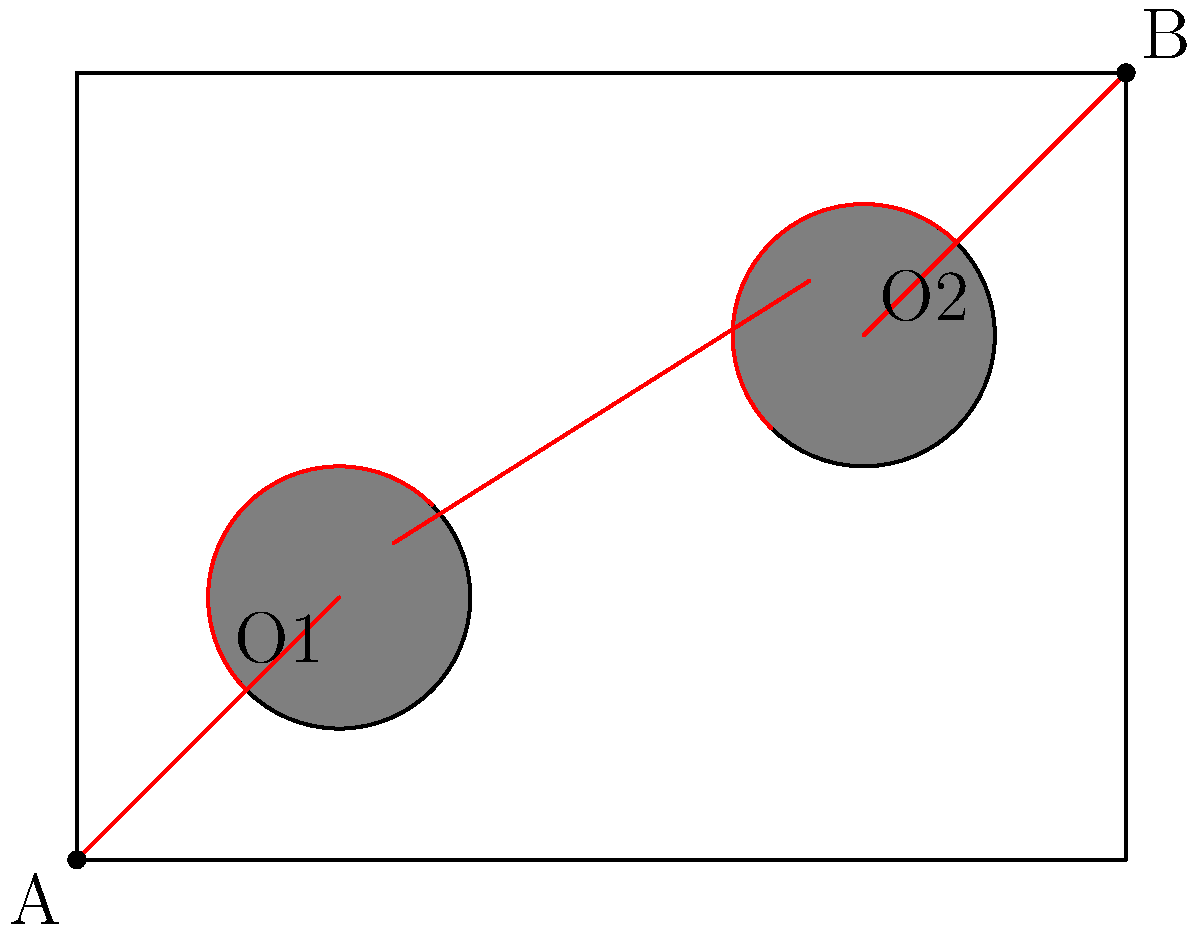In a rectangular room measuring 8 units by 6 units, there are two circular obstacles with radii of 1 unit centered at (2,2) and (6,4). You need to find the shortest path from point A (0,0) to point B (8,6) without passing through the obstacles. What is the length of this path to the nearest tenth of a unit? To find the shortest path, we need to follow these steps:

1) The shortest path will be a straight line from A to B, except where it needs to curve around the obstacles.

2) The path will be tangent to the obstacles, forming two arcs.

3) We can break down the path into five segments:
   a) A to the tangent point on O1
   b) Arc around O1
   c) Straight line between the obstacles
   d) Arc around O2
   e) Tangent point on O2 to B

4) For the straight segments:
   - A to O1 tangent: $\sqrt{(2-1)^2 + (2-1)^2} = \sqrt{2}$
   - Between obstacles: $\sqrt{(6-1-\sqrt{2})^2 + (4-1-\sqrt{2})^2} = 4\sqrt{2}$
   - O2 tangent to B: $\sqrt{(8-7)^2 + (6-5)^2} = \sqrt{2}$

5) For the arcs:
   - Each arc is a quarter circle with radius 1
   - Length of each arc = $\frac{\pi}{2}$

6) Total length:
   $L = \sqrt{2} + \frac{\pi}{2} + 4\sqrt{2} + \frac{\pi}{2} + \sqrt{2}$
   $= 6\sqrt{2} + \pi$
   $\approx 11.8$ units

Therefore, the length of the shortest path is approximately 11.8 units.
Answer: 11.8 units 